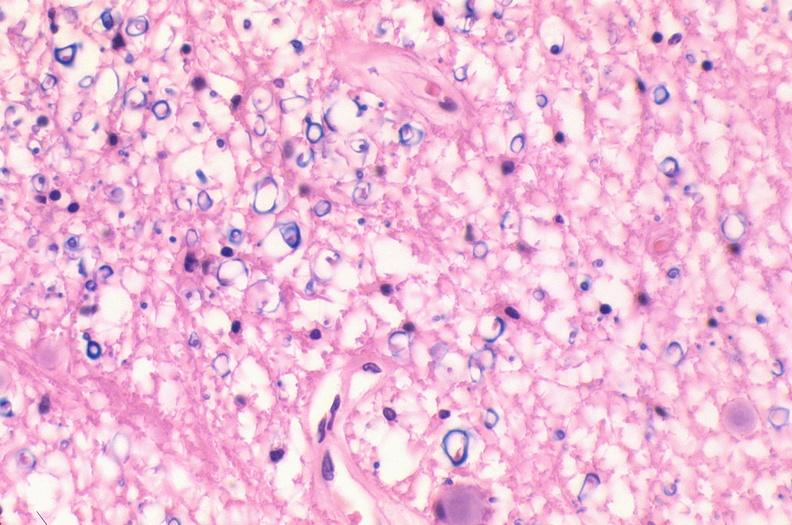what does this image show?
Answer the question using a single word or phrase. Spinal cord injury due to vertebral column trauma 